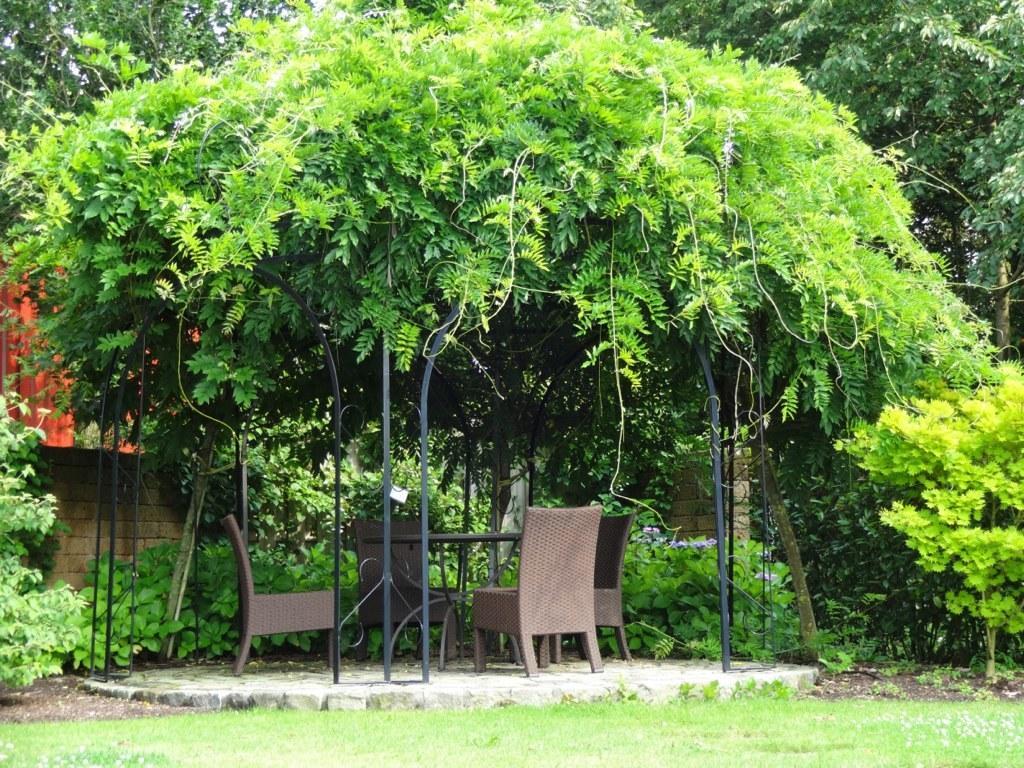Can you describe this image briefly? In this picture I can see number of chairs and table. I can see green grass. I can see trees in the background. I can see the wall. 